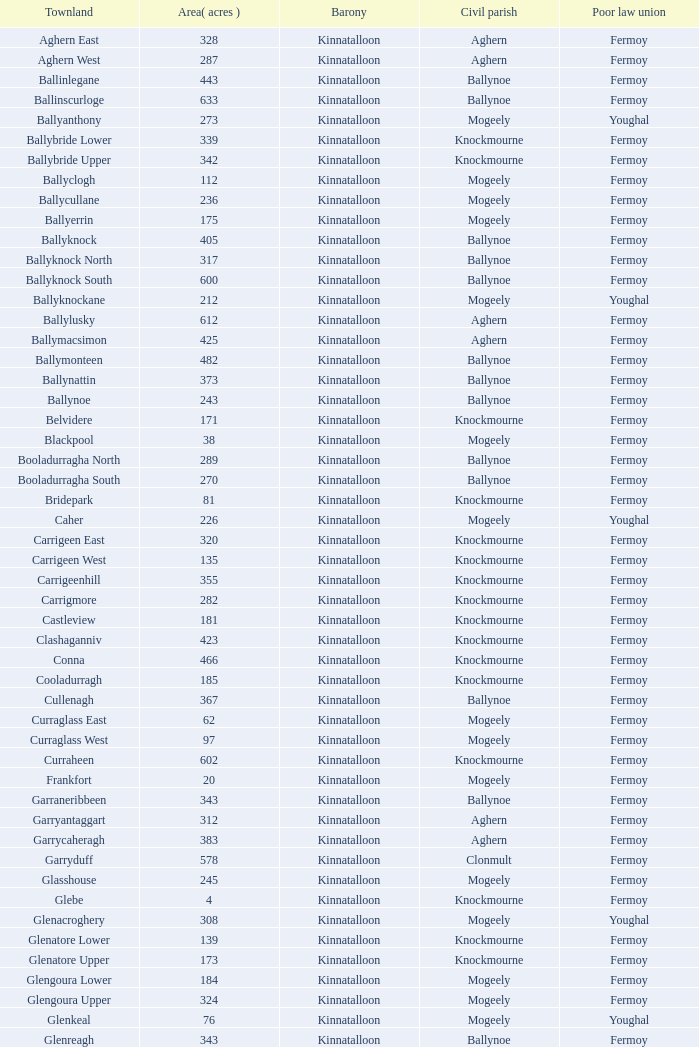Name the civil parish for garryduff Clonmult. 